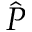<formula> <loc_0><loc_0><loc_500><loc_500>\hat { P }</formula> 